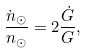Convert formula to latex. <formula><loc_0><loc_0><loc_500><loc_500>\frac { \dot { n } _ { \odot } } { n _ { \odot } } = 2 \frac { \dot { G } } { G } ,</formula> 